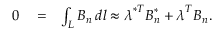Convert formula to latex. <formula><loc_0><loc_0><loc_500><loc_500>\begin{array} { r l r } { 0 } & = } & { \int _ { L } B _ { n } \, d l \approx \lambda ^ { * T } B _ { n } ^ { * } + \lambda ^ { T } B _ { n } . } \end{array}</formula> 